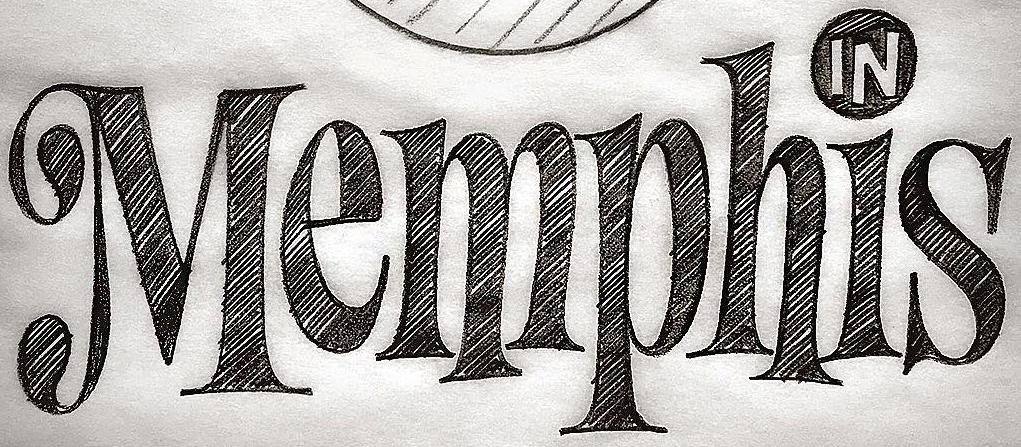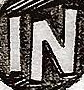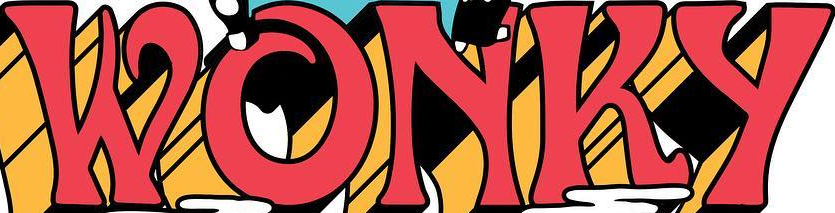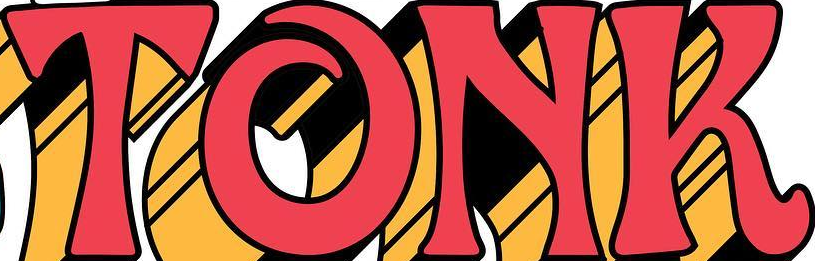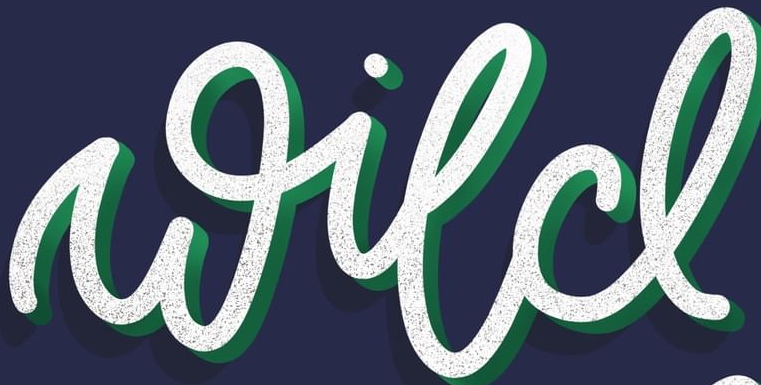What text appears in these images from left to right, separated by a semicolon? Memphis; IN; WONKY; TONK; wild 